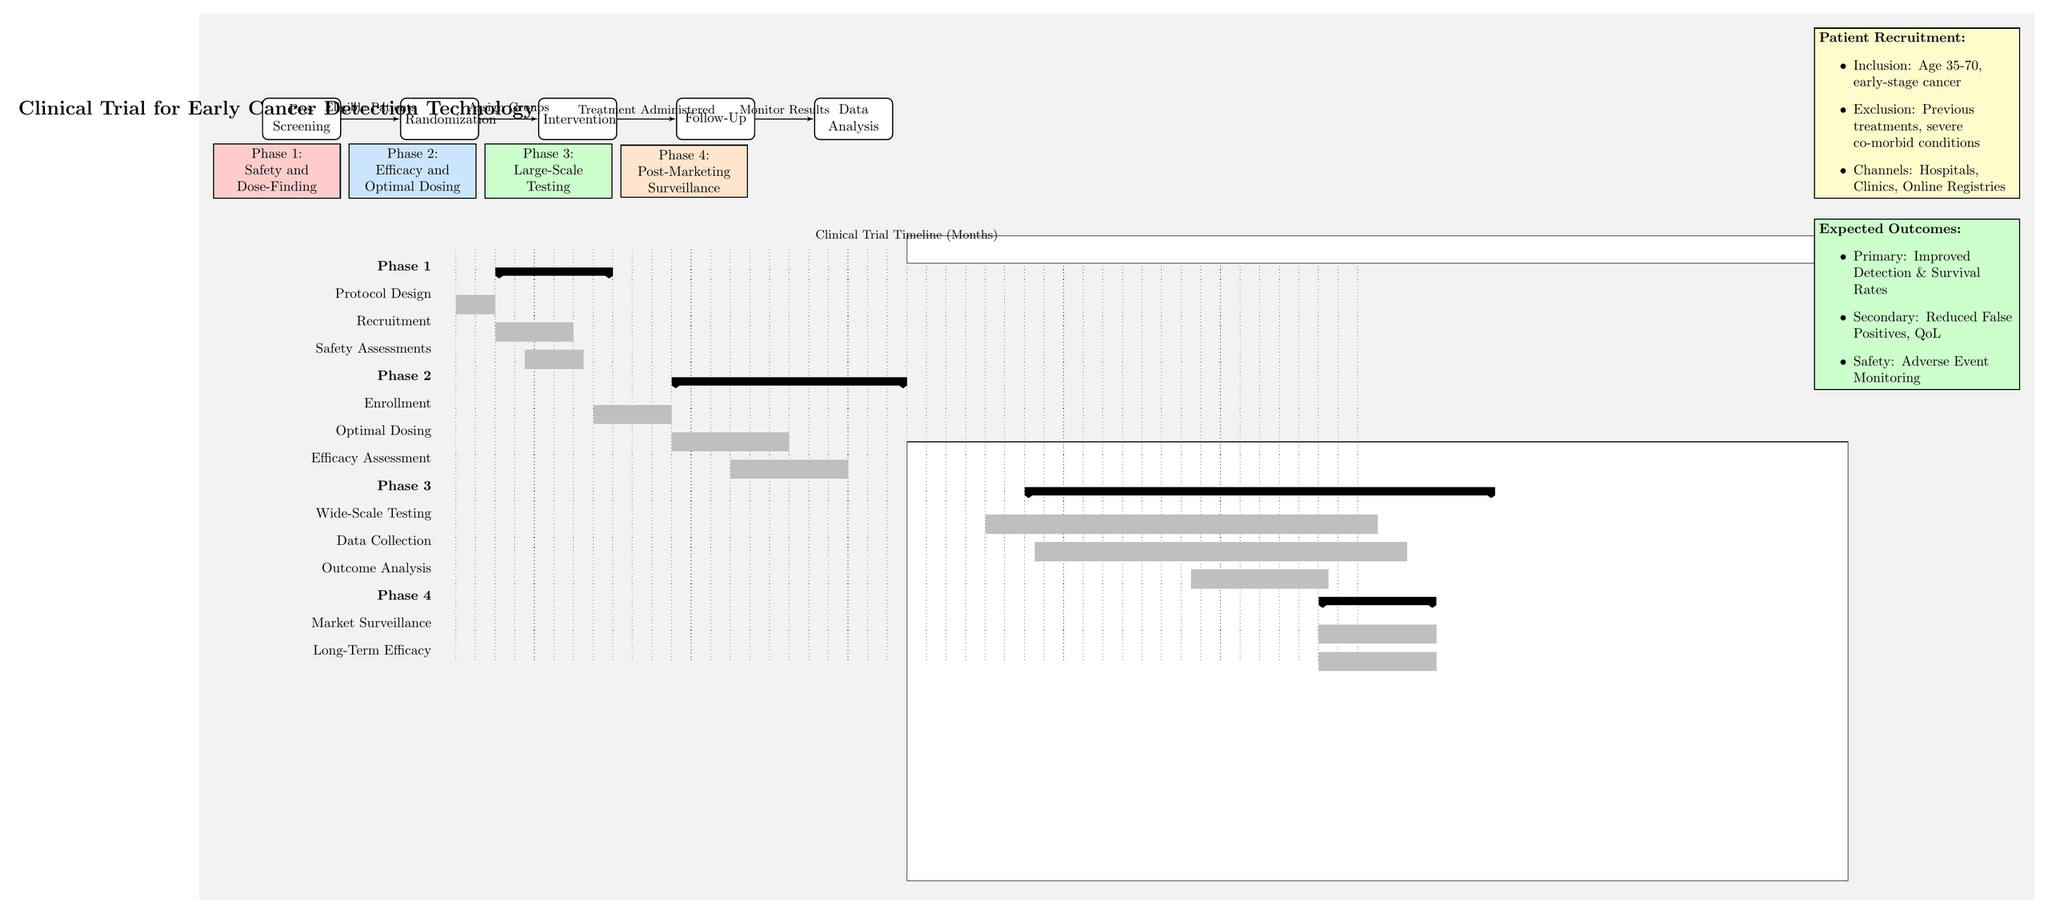What's the total duration of the clinical trial phases? The diagram specifies the clinical trial timeframe from 1 to 48 months. Therefore, the total duration is simply the difference between these two numbers.
Answer: 48 months What is the focus of Phase 1? The diagram indicates that Phase 1 is focused on safety and dose-finding. This is explicitly mentioned in the phase label.
Answer: Safety and Dose-Finding During which months does Phase 3 occur? By examining the Gantt chart, Phase 3 is highlighted as occurring from month 19 to month 42. Therefore, we can identify these months as the duration for this phase.
Answer: Months 19 to 42 What is the purpose of the Follow-Up node? According to the flow diagram, the Follow-Up stage is designed to monitor results after the intervention has been administered. This purpose is explicitly stated in the flow.
Answer: Monitor Results How many bars are shown for Phase 2 in the Gantt chart? The Gantt chart indicates three distinct bars for Phase 2: Enrollment, Optimal Dosing, and Efficacy Assessment. By counting these bars, we can determine the total number.
Answer: 3 What are the inclusion criteria for patient recruitment? The diagram lists the inclusion criteria as age 35-70 and early-stage cancer, which is explicitly noted in the patient recruitment section.
Answer: Age 35-70, early-stage cancer Which phase includes Market Surveillance? The Gantt chart identifies Market Surveillance as part of Phase 4. This phase is listed in the diagram, clearly indicating its placement.
Answer: Phase 4 When is the Outcome Analysis scheduled to take place? By reviewing the Gantt chart, the Outcome Analysis is scheduled from month 36 to month 42. This is directly referenced in the timeline.
Answer: Months 36 to 42 What is a secondary expected outcome? The diagram specifies that a secondary expected outcome is reduced false positives and quality of life. This is detailed in the outcomes section.
Answer: Reduced False Positives, QoL 